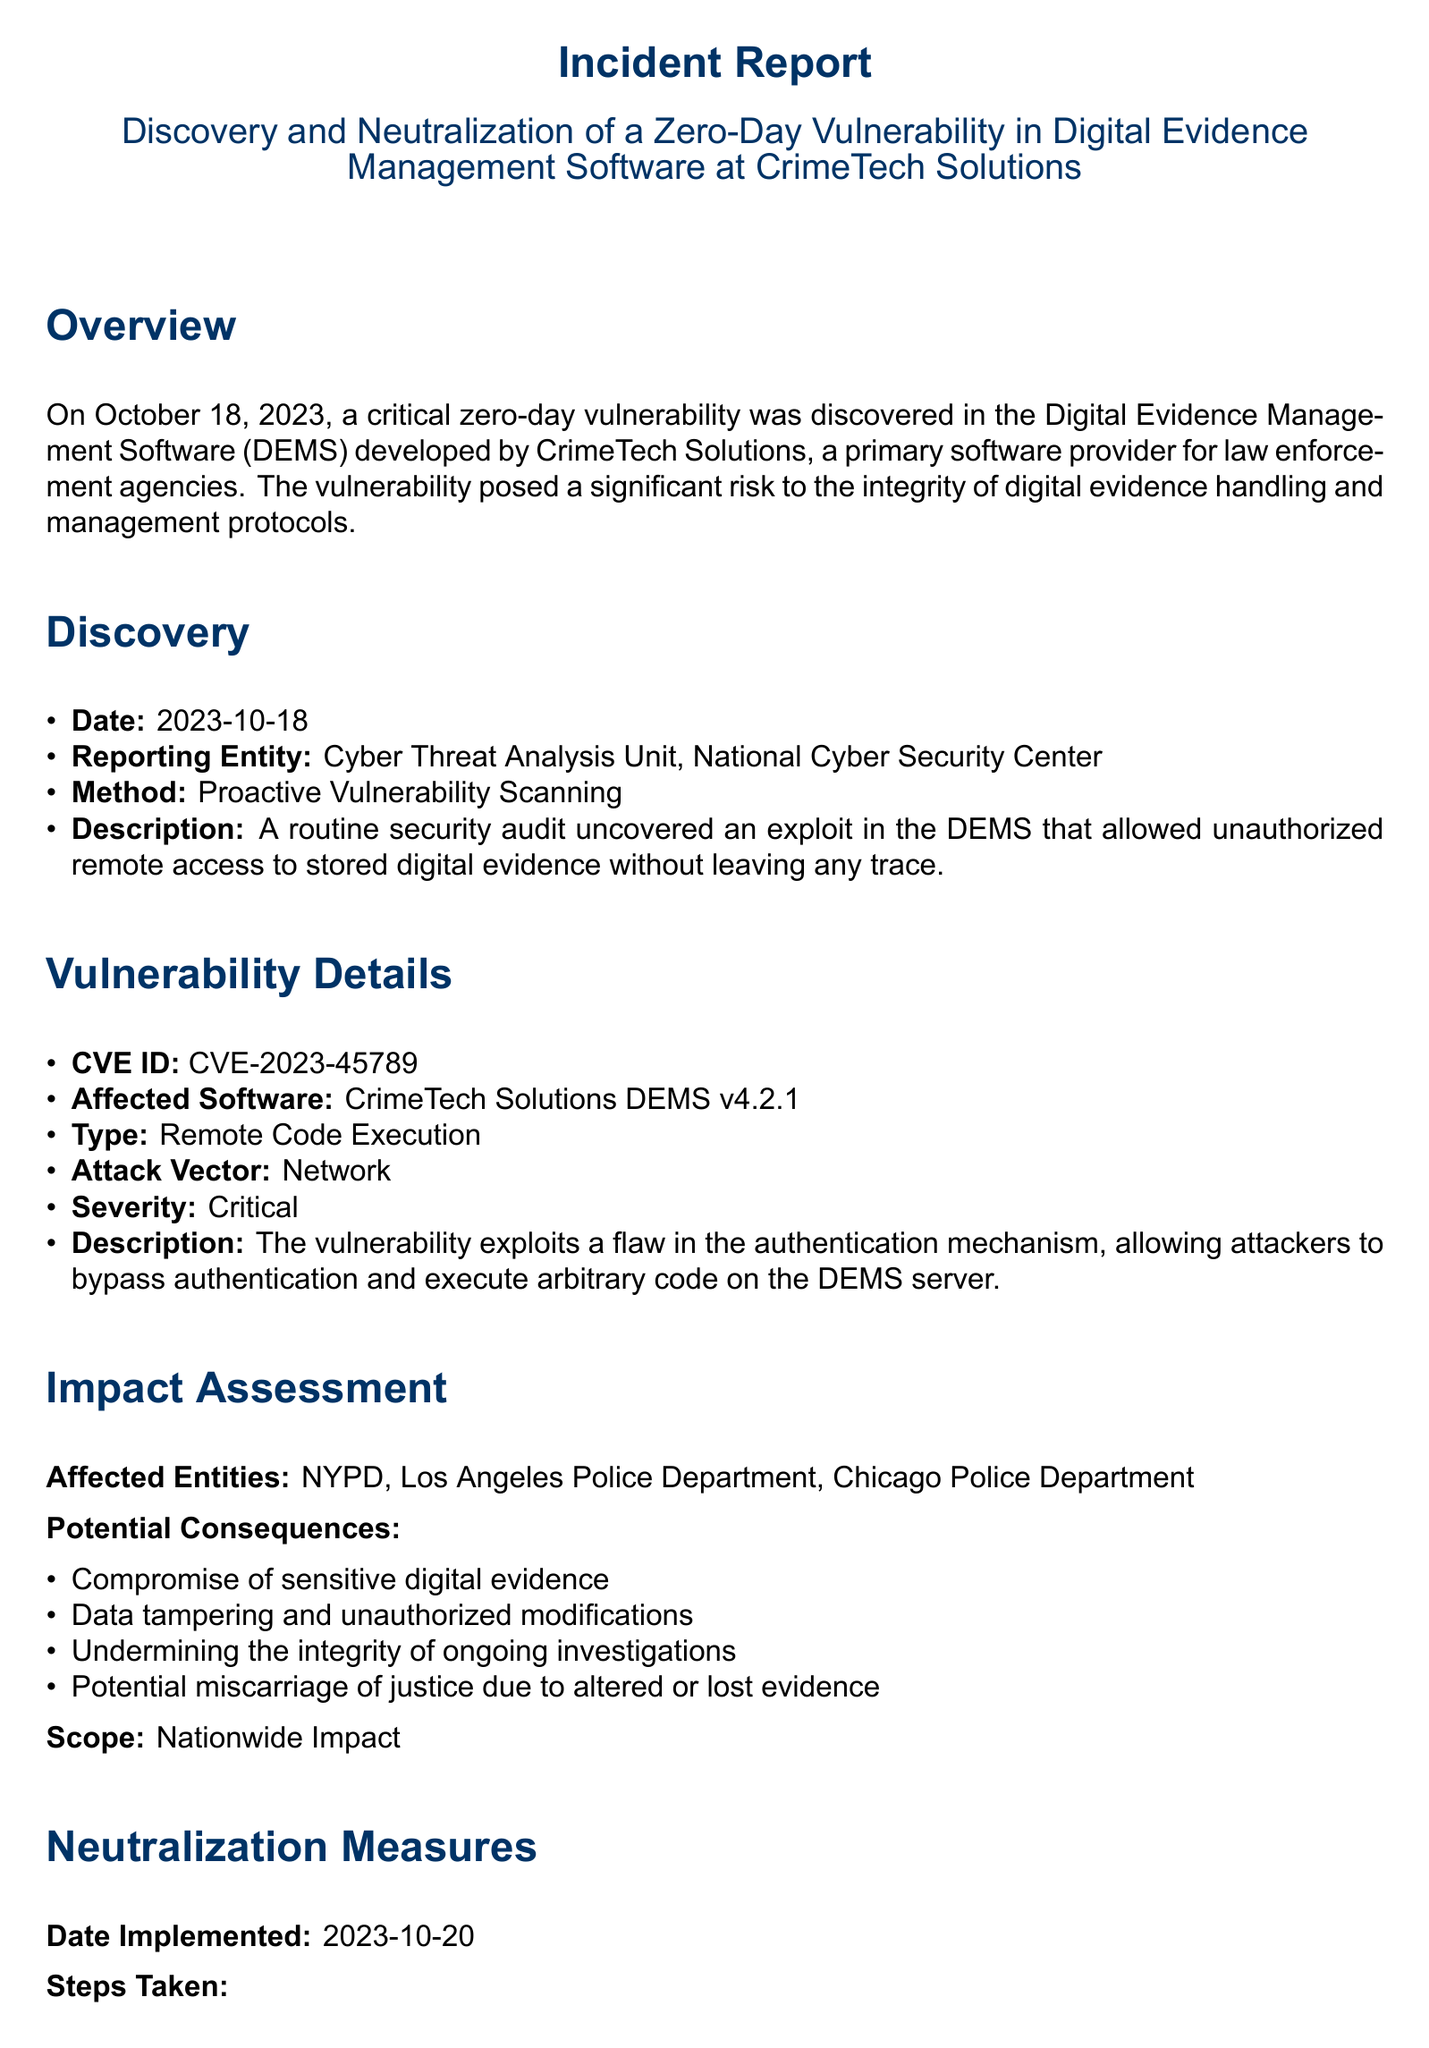What is the date of vulnerability discovery? The document states that the vulnerability was discovered on October 18, 2023.
Answer: October 18, 2023 Who reported the vulnerability? The reporting entity identified in the document is the Cyber Threat Analysis Unit, National Cyber Security Center.
Answer: Cyber Threat Analysis Unit, National Cyber Security Center What is the CVE ID associated with the vulnerability? The document lists the CVE ID as CVE-2023-45789.
Answer: CVE-2023-45789 What is the type of vulnerability discovered? The document categorizes the vulnerability as Remote Code Execution.
Answer: Remote Code Execution What were the potential consequences of the vulnerability? The document outlines multiple potential consequences, one of which is compromise of sensitive digital evidence.
Answer: Compromise of sensitive digital evidence What measures were implemented on the date of 2023-10-20? The document mentions an emergency patch deployment among other measures implemented on that date.
Answer: Emergency Patch Deployment Which police departments were affected by the vulnerability? The affected entities listed in the document include NYPD, Los Angeles Police Department, and Chicago Police Department.
Answer: NYPD, Los Angeles Police Department, Chicago Police Department What is one of the recommended long-term measures? The document recommends adopting a comprehensive monitoring system for DEMS as a long-term measure.
Answer: Adopt a Comprehensive Monitoring System for DEMS What kind of attack vector was identified for the vulnerability? The document specifies that the attack vector for the vulnerability is network.
Answer: Network 